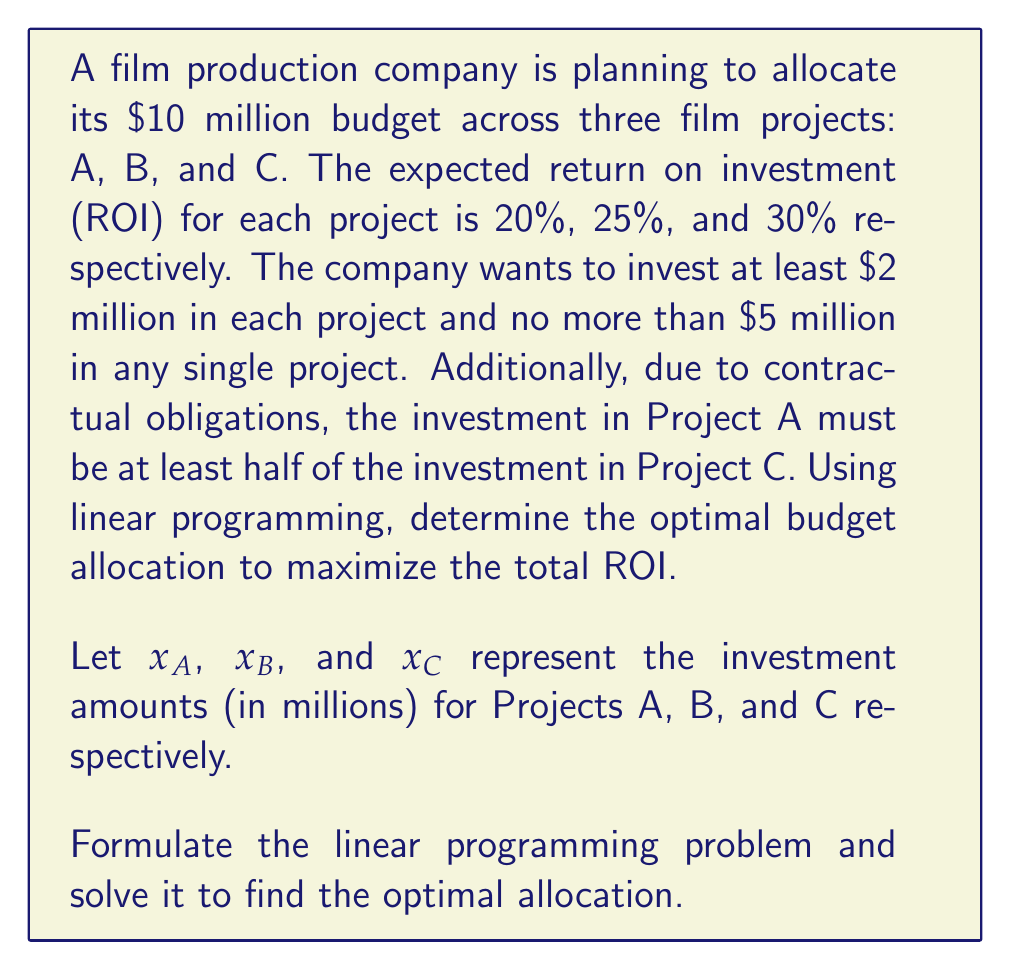Provide a solution to this math problem. To solve this problem, we need to formulate the linear programming model and then solve it. Let's break it down step by step:

1. Objective function:
   We want to maximize the total ROI, which is the sum of each project's investment multiplied by its ROI rate.
   
   Maximize: $$ 0.20x_A + 0.25x_B + 0.30x_C $$

2. Constraints:
   a) Total budget constraint: $$ x_A + x_B + x_C = 10 $$
   b) Minimum investment for each project: $$ x_A \geq 2, x_B \geq 2, x_C \geq 2 $$
   c) Maximum investment for each project: $$ x_A \leq 5, x_B \leq 5, x_C \leq 5 $$
   d) Project A investment at least half of Project C: $$ x_A \geq 0.5x_C $$
   e) Non-negativity: $$ x_A, x_B, x_C \geq 0 $$

3. Solving the linear programming problem:
   We can solve this using the simplex method or a linear programming solver. Let's outline the steps:

   a) Start with a feasible solution: $x_A = 2, x_B = 2, x_C = 6$
   b) Improve the solution by moving along the edges of the feasible region
   c) The optimal solution is reached when no further improvement is possible

4. Optimal solution:
   After solving, we find the optimal allocation:
   $$ x_A = 2.5, x_B = 2.5, x_C = 5 $$

5. Verification:
   - Total budget: $2.5 + 2.5 + 5 = 10$ (constraint satisfied)
   - Minimum and maximum investments: All between 2 and 5 (constraints satisfied)
   - Project A investment: $2.5 \geq 0.5 * 5 = 2.5$ (constraint satisfied)

6. Calculate the maximum total ROI:
   $$ 0.20(2.5) + 0.25(2.5) + 0.30(5) = 0.5 + 0.625 + 1.5 = 2.625 $$

Therefore, the optimal allocation is to invest $2.5 million in Project A, $2.5 million in Project B, and $5 million in Project C, resulting in a maximum total ROI of 2.625 million dollars or 26.25%.
Answer: The optimal budget allocation is:
Project A: $2.5 million
Project B: $2.5 million
Project C: $5 million

This allocation maximizes the total ROI at $2.625 million or 26.25%. 